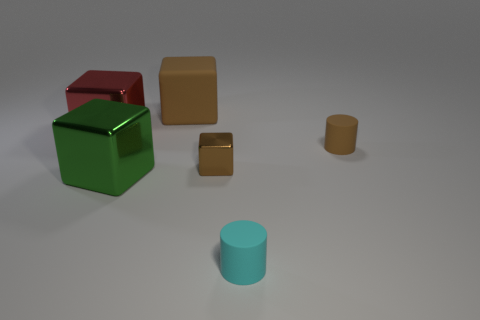Subtract all large cubes. How many cubes are left? 1 Subtract 1 cylinders. How many cylinders are left? 1 Add 1 big purple blocks. How many objects exist? 7 Subtract all green cubes. How many cubes are left? 3 Subtract all gray cubes. How many brown cylinders are left? 1 Subtract all cyan cylinders. Subtract all tiny brown cylinders. How many objects are left? 4 Add 1 tiny cyan matte cylinders. How many tiny cyan matte cylinders are left? 2 Add 3 big shiny things. How many big shiny things exist? 5 Subtract 0 yellow cubes. How many objects are left? 6 Subtract all cylinders. How many objects are left? 4 